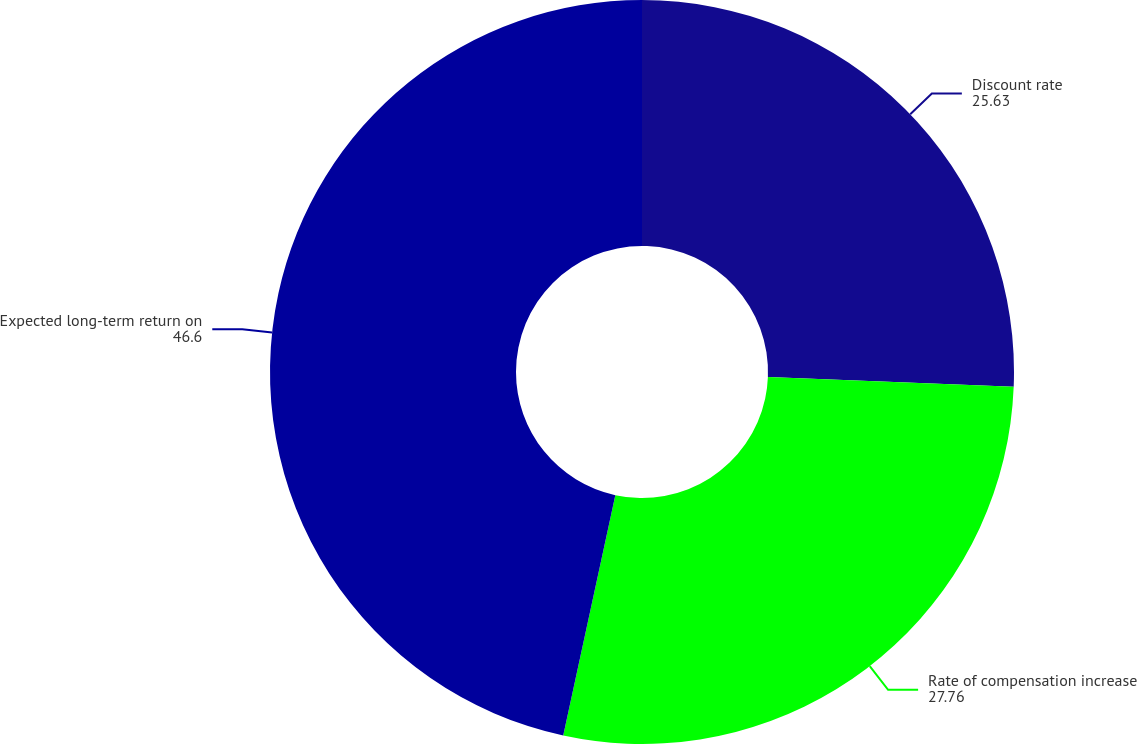Convert chart to OTSL. <chart><loc_0><loc_0><loc_500><loc_500><pie_chart><fcel>Discount rate<fcel>Rate of compensation increase<fcel>Expected long-term return on<nl><fcel>25.63%<fcel>27.76%<fcel>46.6%<nl></chart> 